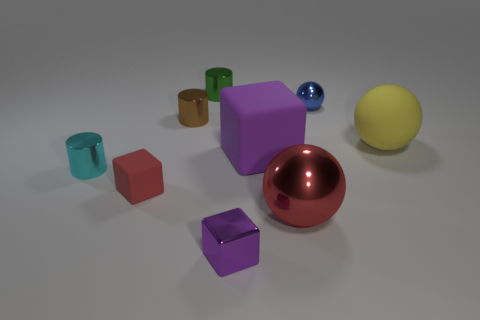Add 1 big purple things. How many objects exist? 10 Subtract all balls. How many objects are left? 6 Subtract 1 cyan cylinders. How many objects are left? 8 Subtract all red shiny things. Subtract all tiny blue shiny objects. How many objects are left? 7 Add 5 matte spheres. How many matte spheres are left? 6 Add 7 large red things. How many large red things exist? 8 